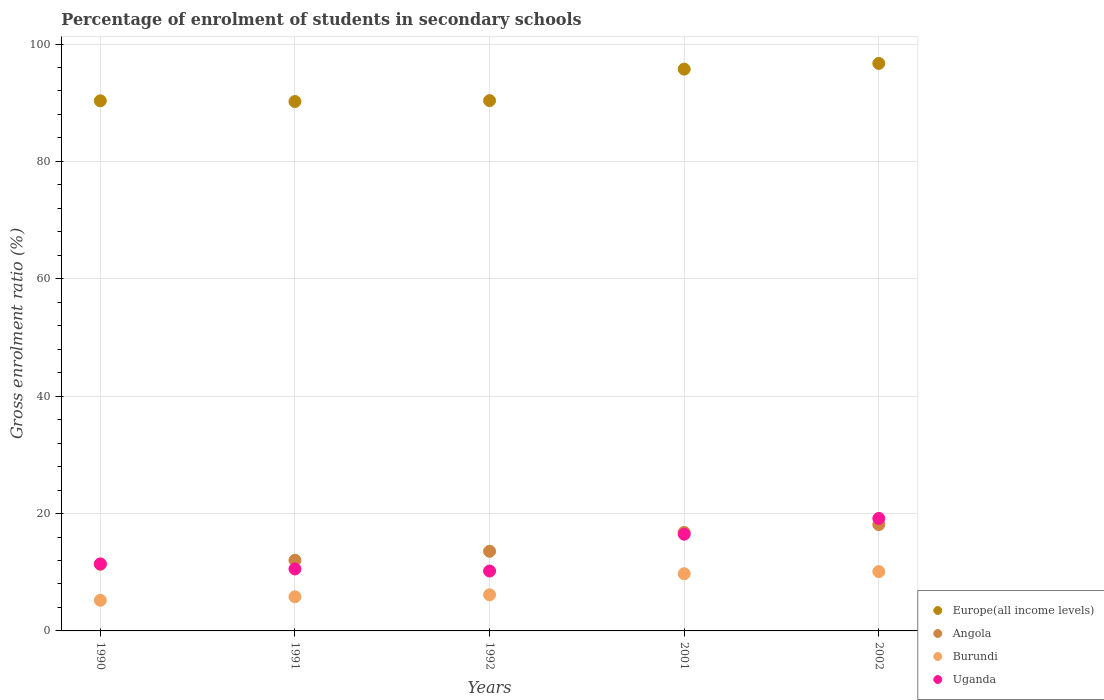How many different coloured dotlines are there?
Provide a short and direct response. 4. What is the percentage of students enrolled in secondary schools in Europe(all income levels) in 1990?
Make the answer very short. 90.32. Across all years, what is the maximum percentage of students enrolled in secondary schools in Europe(all income levels)?
Give a very brief answer. 96.69. Across all years, what is the minimum percentage of students enrolled in secondary schools in Angola?
Your answer should be very brief. 11.36. In which year was the percentage of students enrolled in secondary schools in Uganda minimum?
Keep it short and to the point. 1992. What is the total percentage of students enrolled in secondary schools in Europe(all income levels) in the graph?
Offer a terse response. 463.3. What is the difference between the percentage of students enrolled in secondary schools in Europe(all income levels) in 1990 and that in 2002?
Ensure brevity in your answer.  -6.37. What is the difference between the percentage of students enrolled in secondary schools in Uganda in 2001 and the percentage of students enrolled in secondary schools in Europe(all income levels) in 1990?
Provide a short and direct response. -73.85. What is the average percentage of students enrolled in secondary schools in Burundi per year?
Ensure brevity in your answer.  7.41. In the year 1992, what is the difference between the percentage of students enrolled in secondary schools in Uganda and percentage of students enrolled in secondary schools in Burundi?
Offer a very short reply. 4.05. What is the ratio of the percentage of students enrolled in secondary schools in Uganda in 1990 to that in 2002?
Provide a short and direct response. 0.6. Is the difference between the percentage of students enrolled in secondary schools in Uganda in 1992 and 2002 greater than the difference between the percentage of students enrolled in secondary schools in Burundi in 1992 and 2002?
Your answer should be very brief. No. What is the difference between the highest and the second highest percentage of students enrolled in secondary schools in Uganda?
Make the answer very short. 2.69. What is the difference between the highest and the lowest percentage of students enrolled in secondary schools in Burundi?
Offer a very short reply. 4.89. Is the sum of the percentage of students enrolled in secondary schools in Angola in 1991 and 1992 greater than the maximum percentage of students enrolled in secondary schools in Europe(all income levels) across all years?
Keep it short and to the point. No. Is it the case that in every year, the sum of the percentage of students enrolled in secondary schools in Burundi and percentage of students enrolled in secondary schools in Angola  is greater than the sum of percentage of students enrolled in secondary schools in Europe(all income levels) and percentage of students enrolled in secondary schools in Uganda?
Your response must be concise. Yes. Is the percentage of students enrolled in secondary schools in Burundi strictly greater than the percentage of students enrolled in secondary schools in Angola over the years?
Offer a terse response. No. Is the percentage of students enrolled in secondary schools in Europe(all income levels) strictly less than the percentage of students enrolled in secondary schools in Uganda over the years?
Make the answer very short. No. How many years are there in the graph?
Give a very brief answer. 5. What is the difference between two consecutive major ticks on the Y-axis?
Your response must be concise. 20. Does the graph contain any zero values?
Keep it short and to the point. No. Where does the legend appear in the graph?
Ensure brevity in your answer.  Bottom right. How are the legend labels stacked?
Give a very brief answer. Vertical. What is the title of the graph?
Your answer should be compact. Percentage of enrolment of students in secondary schools. Does "United Kingdom" appear as one of the legend labels in the graph?
Your answer should be compact. No. What is the label or title of the X-axis?
Offer a terse response. Years. What is the label or title of the Y-axis?
Your response must be concise. Gross enrolment ratio (%). What is the Gross enrolment ratio (%) in Europe(all income levels) in 1990?
Your response must be concise. 90.32. What is the Gross enrolment ratio (%) of Angola in 1990?
Offer a terse response. 11.36. What is the Gross enrolment ratio (%) of Burundi in 1990?
Make the answer very short. 5.22. What is the Gross enrolment ratio (%) in Uganda in 1990?
Make the answer very short. 11.42. What is the Gross enrolment ratio (%) in Europe(all income levels) in 1991?
Ensure brevity in your answer.  90.2. What is the Gross enrolment ratio (%) of Angola in 1991?
Keep it short and to the point. 12.04. What is the Gross enrolment ratio (%) in Burundi in 1991?
Your response must be concise. 5.82. What is the Gross enrolment ratio (%) in Uganda in 1991?
Make the answer very short. 10.56. What is the Gross enrolment ratio (%) in Europe(all income levels) in 1992?
Offer a terse response. 90.36. What is the Gross enrolment ratio (%) of Angola in 1992?
Provide a short and direct response. 13.57. What is the Gross enrolment ratio (%) in Burundi in 1992?
Offer a very short reply. 6.16. What is the Gross enrolment ratio (%) of Uganda in 1992?
Your answer should be very brief. 10.2. What is the Gross enrolment ratio (%) in Europe(all income levels) in 2001?
Offer a terse response. 95.72. What is the Gross enrolment ratio (%) in Angola in 2001?
Provide a short and direct response. 16.78. What is the Gross enrolment ratio (%) of Burundi in 2001?
Make the answer very short. 9.75. What is the Gross enrolment ratio (%) of Uganda in 2001?
Offer a very short reply. 16.48. What is the Gross enrolment ratio (%) of Europe(all income levels) in 2002?
Keep it short and to the point. 96.69. What is the Gross enrolment ratio (%) of Angola in 2002?
Make the answer very short. 18.11. What is the Gross enrolment ratio (%) of Burundi in 2002?
Offer a very short reply. 10.11. What is the Gross enrolment ratio (%) of Uganda in 2002?
Your answer should be compact. 19.16. Across all years, what is the maximum Gross enrolment ratio (%) in Europe(all income levels)?
Offer a very short reply. 96.69. Across all years, what is the maximum Gross enrolment ratio (%) of Angola?
Provide a short and direct response. 18.11. Across all years, what is the maximum Gross enrolment ratio (%) of Burundi?
Your response must be concise. 10.11. Across all years, what is the maximum Gross enrolment ratio (%) in Uganda?
Offer a terse response. 19.16. Across all years, what is the minimum Gross enrolment ratio (%) in Europe(all income levels)?
Ensure brevity in your answer.  90.2. Across all years, what is the minimum Gross enrolment ratio (%) of Angola?
Provide a short and direct response. 11.36. Across all years, what is the minimum Gross enrolment ratio (%) of Burundi?
Provide a succinct answer. 5.22. Across all years, what is the minimum Gross enrolment ratio (%) of Uganda?
Give a very brief answer. 10.2. What is the total Gross enrolment ratio (%) in Europe(all income levels) in the graph?
Provide a succinct answer. 463.3. What is the total Gross enrolment ratio (%) of Angola in the graph?
Offer a very short reply. 71.87. What is the total Gross enrolment ratio (%) of Burundi in the graph?
Your answer should be compact. 37.05. What is the total Gross enrolment ratio (%) of Uganda in the graph?
Ensure brevity in your answer.  67.82. What is the difference between the Gross enrolment ratio (%) in Europe(all income levels) in 1990 and that in 1991?
Ensure brevity in your answer.  0.12. What is the difference between the Gross enrolment ratio (%) of Angola in 1990 and that in 1991?
Ensure brevity in your answer.  -0.68. What is the difference between the Gross enrolment ratio (%) in Burundi in 1990 and that in 1991?
Keep it short and to the point. -0.6. What is the difference between the Gross enrolment ratio (%) of Uganda in 1990 and that in 1991?
Offer a terse response. 0.86. What is the difference between the Gross enrolment ratio (%) in Europe(all income levels) in 1990 and that in 1992?
Offer a very short reply. -0.04. What is the difference between the Gross enrolment ratio (%) of Angola in 1990 and that in 1992?
Ensure brevity in your answer.  -2.21. What is the difference between the Gross enrolment ratio (%) in Burundi in 1990 and that in 1992?
Keep it short and to the point. -0.94. What is the difference between the Gross enrolment ratio (%) in Uganda in 1990 and that in 1992?
Ensure brevity in your answer.  1.21. What is the difference between the Gross enrolment ratio (%) in Europe(all income levels) in 1990 and that in 2001?
Your answer should be compact. -5.4. What is the difference between the Gross enrolment ratio (%) in Angola in 1990 and that in 2001?
Provide a short and direct response. -5.43. What is the difference between the Gross enrolment ratio (%) of Burundi in 1990 and that in 2001?
Provide a short and direct response. -4.53. What is the difference between the Gross enrolment ratio (%) of Uganda in 1990 and that in 2001?
Your response must be concise. -5.06. What is the difference between the Gross enrolment ratio (%) in Europe(all income levels) in 1990 and that in 2002?
Keep it short and to the point. -6.37. What is the difference between the Gross enrolment ratio (%) in Angola in 1990 and that in 2002?
Offer a terse response. -6.76. What is the difference between the Gross enrolment ratio (%) in Burundi in 1990 and that in 2002?
Ensure brevity in your answer.  -4.89. What is the difference between the Gross enrolment ratio (%) of Uganda in 1990 and that in 2002?
Ensure brevity in your answer.  -7.75. What is the difference between the Gross enrolment ratio (%) in Europe(all income levels) in 1991 and that in 1992?
Your answer should be very brief. -0.16. What is the difference between the Gross enrolment ratio (%) of Angola in 1991 and that in 1992?
Keep it short and to the point. -1.53. What is the difference between the Gross enrolment ratio (%) in Burundi in 1991 and that in 1992?
Make the answer very short. -0.33. What is the difference between the Gross enrolment ratio (%) in Uganda in 1991 and that in 1992?
Provide a succinct answer. 0.35. What is the difference between the Gross enrolment ratio (%) of Europe(all income levels) in 1991 and that in 2001?
Your response must be concise. -5.52. What is the difference between the Gross enrolment ratio (%) in Angola in 1991 and that in 2001?
Give a very brief answer. -4.75. What is the difference between the Gross enrolment ratio (%) of Burundi in 1991 and that in 2001?
Give a very brief answer. -3.92. What is the difference between the Gross enrolment ratio (%) in Uganda in 1991 and that in 2001?
Your response must be concise. -5.92. What is the difference between the Gross enrolment ratio (%) of Europe(all income levels) in 1991 and that in 2002?
Your response must be concise. -6.49. What is the difference between the Gross enrolment ratio (%) in Angola in 1991 and that in 2002?
Offer a very short reply. -6.08. What is the difference between the Gross enrolment ratio (%) in Burundi in 1991 and that in 2002?
Provide a succinct answer. -4.29. What is the difference between the Gross enrolment ratio (%) in Uganda in 1991 and that in 2002?
Keep it short and to the point. -8.61. What is the difference between the Gross enrolment ratio (%) in Europe(all income levels) in 1992 and that in 2001?
Your answer should be very brief. -5.36. What is the difference between the Gross enrolment ratio (%) of Angola in 1992 and that in 2001?
Offer a terse response. -3.22. What is the difference between the Gross enrolment ratio (%) in Burundi in 1992 and that in 2001?
Provide a succinct answer. -3.59. What is the difference between the Gross enrolment ratio (%) in Uganda in 1992 and that in 2001?
Make the answer very short. -6.27. What is the difference between the Gross enrolment ratio (%) in Europe(all income levels) in 1992 and that in 2002?
Your response must be concise. -6.34. What is the difference between the Gross enrolment ratio (%) in Angola in 1992 and that in 2002?
Your response must be concise. -4.55. What is the difference between the Gross enrolment ratio (%) of Burundi in 1992 and that in 2002?
Your response must be concise. -3.95. What is the difference between the Gross enrolment ratio (%) of Uganda in 1992 and that in 2002?
Offer a terse response. -8.96. What is the difference between the Gross enrolment ratio (%) of Europe(all income levels) in 2001 and that in 2002?
Offer a very short reply. -0.97. What is the difference between the Gross enrolment ratio (%) of Angola in 2001 and that in 2002?
Your answer should be compact. -1.33. What is the difference between the Gross enrolment ratio (%) in Burundi in 2001 and that in 2002?
Offer a very short reply. -0.36. What is the difference between the Gross enrolment ratio (%) in Uganda in 2001 and that in 2002?
Give a very brief answer. -2.69. What is the difference between the Gross enrolment ratio (%) in Europe(all income levels) in 1990 and the Gross enrolment ratio (%) in Angola in 1991?
Your answer should be compact. 78.28. What is the difference between the Gross enrolment ratio (%) of Europe(all income levels) in 1990 and the Gross enrolment ratio (%) of Burundi in 1991?
Provide a succinct answer. 84.5. What is the difference between the Gross enrolment ratio (%) in Europe(all income levels) in 1990 and the Gross enrolment ratio (%) in Uganda in 1991?
Offer a very short reply. 79.77. What is the difference between the Gross enrolment ratio (%) in Angola in 1990 and the Gross enrolment ratio (%) in Burundi in 1991?
Offer a terse response. 5.54. What is the difference between the Gross enrolment ratio (%) of Angola in 1990 and the Gross enrolment ratio (%) of Uganda in 1991?
Provide a succinct answer. 0.8. What is the difference between the Gross enrolment ratio (%) of Burundi in 1990 and the Gross enrolment ratio (%) of Uganda in 1991?
Provide a succinct answer. -5.34. What is the difference between the Gross enrolment ratio (%) in Europe(all income levels) in 1990 and the Gross enrolment ratio (%) in Angola in 1992?
Your response must be concise. 76.75. What is the difference between the Gross enrolment ratio (%) in Europe(all income levels) in 1990 and the Gross enrolment ratio (%) in Burundi in 1992?
Offer a terse response. 84.16. What is the difference between the Gross enrolment ratio (%) in Europe(all income levels) in 1990 and the Gross enrolment ratio (%) in Uganda in 1992?
Keep it short and to the point. 80.12. What is the difference between the Gross enrolment ratio (%) of Angola in 1990 and the Gross enrolment ratio (%) of Burundi in 1992?
Your answer should be very brief. 5.2. What is the difference between the Gross enrolment ratio (%) of Angola in 1990 and the Gross enrolment ratio (%) of Uganda in 1992?
Your answer should be compact. 1.15. What is the difference between the Gross enrolment ratio (%) of Burundi in 1990 and the Gross enrolment ratio (%) of Uganda in 1992?
Give a very brief answer. -4.99. What is the difference between the Gross enrolment ratio (%) of Europe(all income levels) in 1990 and the Gross enrolment ratio (%) of Angola in 2001?
Provide a short and direct response. 73.54. What is the difference between the Gross enrolment ratio (%) in Europe(all income levels) in 1990 and the Gross enrolment ratio (%) in Burundi in 2001?
Make the answer very short. 80.58. What is the difference between the Gross enrolment ratio (%) of Europe(all income levels) in 1990 and the Gross enrolment ratio (%) of Uganda in 2001?
Your answer should be compact. 73.85. What is the difference between the Gross enrolment ratio (%) of Angola in 1990 and the Gross enrolment ratio (%) of Burundi in 2001?
Your answer should be very brief. 1.61. What is the difference between the Gross enrolment ratio (%) of Angola in 1990 and the Gross enrolment ratio (%) of Uganda in 2001?
Provide a succinct answer. -5.12. What is the difference between the Gross enrolment ratio (%) of Burundi in 1990 and the Gross enrolment ratio (%) of Uganda in 2001?
Offer a very short reply. -11.26. What is the difference between the Gross enrolment ratio (%) of Europe(all income levels) in 1990 and the Gross enrolment ratio (%) of Angola in 2002?
Your answer should be compact. 72.21. What is the difference between the Gross enrolment ratio (%) of Europe(all income levels) in 1990 and the Gross enrolment ratio (%) of Burundi in 2002?
Provide a short and direct response. 80.21. What is the difference between the Gross enrolment ratio (%) in Europe(all income levels) in 1990 and the Gross enrolment ratio (%) in Uganda in 2002?
Keep it short and to the point. 71.16. What is the difference between the Gross enrolment ratio (%) in Angola in 1990 and the Gross enrolment ratio (%) in Burundi in 2002?
Provide a short and direct response. 1.25. What is the difference between the Gross enrolment ratio (%) in Angola in 1990 and the Gross enrolment ratio (%) in Uganda in 2002?
Ensure brevity in your answer.  -7.81. What is the difference between the Gross enrolment ratio (%) of Burundi in 1990 and the Gross enrolment ratio (%) of Uganda in 2002?
Keep it short and to the point. -13.95. What is the difference between the Gross enrolment ratio (%) in Europe(all income levels) in 1991 and the Gross enrolment ratio (%) in Angola in 1992?
Make the answer very short. 76.63. What is the difference between the Gross enrolment ratio (%) of Europe(all income levels) in 1991 and the Gross enrolment ratio (%) of Burundi in 1992?
Give a very brief answer. 84.04. What is the difference between the Gross enrolment ratio (%) in Europe(all income levels) in 1991 and the Gross enrolment ratio (%) in Uganda in 1992?
Provide a succinct answer. 80. What is the difference between the Gross enrolment ratio (%) of Angola in 1991 and the Gross enrolment ratio (%) of Burundi in 1992?
Your response must be concise. 5.88. What is the difference between the Gross enrolment ratio (%) of Angola in 1991 and the Gross enrolment ratio (%) of Uganda in 1992?
Your answer should be very brief. 1.83. What is the difference between the Gross enrolment ratio (%) in Burundi in 1991 and the Gross enrolment ratio (%) in Uganda in 1992?
Provide a short and direct response. -4.38. What is the difference between the Gross enrolment ratio (%) in Europe(all income levels) in 1991 and the Gross enrolment ratio (%) in Angola in 2001?
Offer a very short reply. 73.42. What is the difference between the Gross enrolment ratio (%) of Europe(all income levels) in 1991 and the Gross enrolment ratio (%) of Burundi in 2001?
Your answer should be very brief. 80.46. What is the difference between the Gross enrolment ratio (%) in Europe(all income levels) in 1991 and the Gross enrolment ratio (%) in Uganda in 2001?
Offer a terse response. 73.72. What is the difference between the Gross enrolment ratio (%) of Angola in 1991 and the Gross enrolment ratio (%) of Burundi in 2001?
Your answer should be very brief. 2.29. What is the difference between the Gross enrolment ratio (%) of Angola in 1991 and the Gross enrolment ratio (%) of Uganda in 2001?
Ensure brevity in your answer.  -4.44. What is the difference between the Gross enrolment ratio (%) in Burundi in 1991 and the Gross enrolment ratio (%) in Uganda in 2001?
Keep it short and to the point. -10.65. What is the difference between the Gross enrolment ratio (%) of Europe(all income levels) in 1991 and the Gross enrolment ratio (%) of Angola in 2002?
Provide a short and direct response. 72.09. What is the difference between the Gross enrolment ratio (%) of Europe(all income levels) in 1991 and the Gross enrolment ratio (%) of Burundi in 2002?
Your answer should be compact. 80.09. What is the difference between the Gross enrolment ratio (%) in Europe(all income levels) in 1991 and the Gross enrolment ratio (%) in Uganda in 2002?
Make the answer very short. 71.04. What is the difference between the Gross enrolment ratio (%) of Angola in 1991 and the Gross enrolment ratio (%) of Burundi in 2002?
Offer a terse response. 1.93. What is the difference between the Gross enrolment ratio (%) in Angola in 1991 and the Gross enrolment ratio (%) in Uganda in 2002?
Your answer should be compact. -7.13. What is the difference between the Gross enrolment ratio (%) in Burundi in 1991 and the Gross enrolment ratio (%) in Uganda in 2002?
Provide a short and direct response. -13.34. What is the difference between the Gross enrolment ratio (%) in Europe(all income levels) in 1992 and the Gross enrolment ratio (%) in Angola in 2001?
Provide a short and direct response. 73.57. What is the difference between the Gross enrolment ratio (%) of Europe(all income levels) in 1992 and the Gross enrolment ratio (%) of Burundi in 2001?
Your answer should be very brief. 80.61. What is the difference between the Gross enrolment ratio (%) in Europe(all income levels) in 1992 and the Gross enrolment ratio (%) in Uganda in 2001?
Provide a succinct answer. 73.88. What is the difference between the Gross enrolment ratio (%) of Angola in 1992 and the Gross enrolment ratio (%) of Burundi in 2001?
Make the answer very short. 3.82. What is the difference between the Gross enrolment ratio (%) in Angola in 1992 and the Gross enrolment ratio (%) in Uganda in 2001?
Offer a terse response. -2.91. What is the difference between the Gross enrolment ratio (%) of Burundi in 1992 and the Gross enrolment ratio (%) of Uganda in 2001?
Your response must be concise. -10.32. What is the difference between the Gross enrolment ratio (%) in Europe(all income levels) in 1992 and the Gross enrolment ratio (%) in Angola in 2002?
Your answer should be compact. 72.24. What is the difference between the Gross enrolment ratio (%) of Europe(all income levels) in 1992 and the Gross enrolment ratio (%) of Burundi in 2002?
Your answer should be very brief. 80.25. What is the difference between the Gross enrolment ratio (%) of Europe(all income levels) in 1992 and the Gross enrolment ratio (%) of Uganda in 2002?
Offer a very short reply. 71.19. What is the difference between the Gross enrolment ratio (%) in Angola in 1992 and the Gross enrolment ratio (%) in Burundi in 2002?
Make the answer very short. 3.46. What is the difference between the Gross enrolment ratio (%) of Angola in 1992 and the Gross enrolment ratio (%) of Uganda in 2002?
Your answer should be very brief. -5.6. What is the difference between the Gross enrolment ratio (%) of Burundi in 1992 and the Gross enrolment ratio (%) of Uganda in 2002?
Provide a succinct answer. -13.01. What is the difference between the Gross enrolment ratio (%) in Europe(all income levels) in 2001 and the Gross enrolment ratio (%) in Angola in 2002?
Your response must be concise. 77.61. What is the difference between the Gross enrolment ratio (%) of Europe(all income levels) in 2001 and the Gross enrolment ratio (%) of Burundi in 2002?
Make the answer very short. 85.61. What is the difference between the Gross enrolment ratio (%) in Europe(all income levels) in 2001 and the Gross enrolment ratio (%) in Uganda in 2002?
Ensure brevity in your answer.  76.56. What is the difference between the Gross enrolment ratio (%) in Angola in 2001 and the Gross enrolment ratio (%) in Burundi in 2002?
Provide a succinct answer. 6.67. What is the difference between the Gross enrolment ratio (%) of Angola in 2001 and the Gross enrolment ratio (%) of Uganda in 2002?
Offer a terse response. -2.38. What is the difference between the Gross enrolment ratio (%) of Burundi in 2001 and the Gross enrolment ratio (%) of Uganda in 2002?
Give a very brief answer. -9.42. What is the average Gross enrolment ratio (%) of Europe(all income levels) per year?
Provide a succinct answer. 92.66. What is the average Gross enrolment ratio (%) in Angola per year?
Your answer should be compact. 14.37. What is the average Gross enrolment ratio (%) in Burundi per year?
Offer a very short reply. 7.41. What is the average Gross enrolment ratio (%) of Uganda per year?
Your answer should be compact. 13.56. In the year 1990, what is the difference between the Gross enrolment ratio (%) of Europe(all income levels) and Gross enrolment ratio (%) of Angola?
Provide a succinct answer. 78.96. In the year 1990, what is the difference between the Gross enrolment ratio (%) in Europe(all income levels) and Gross enrolment ratio (%) in Burundi?
Provide a succinct answer. 85.1. In the year 1990, what is the difference between the Gross enrolment ratio (%) in Europe(all income levels) and Gross enrolment ratio (%) in Uganda?
Keep it short and to the point. 78.9. In the year 1990, what is the difference between the Gross enrolment ratio (%) in Angola and Gross enrolment ratio (%) in Burundi?
Provide a short and direct response. 6.14. In the year 1990, what is the difference between the Gross enrolment ratio (%) of Angola and Gross enrolment ratio (%) of Uganda?
Offer a very short reply. -0.06. In the year 1990, what is the difference between the Gross enrolment ratio (%) in Burundi and Gross enrolment ratio (%) in Uganda?
Ensure brevity in your answer.  -6.2. In the year 1991, what is the difference between the Gross enrolment ratio (%) in Europe(all income levels) and Gross enrolment ratio (%) in Angola?
Ensure brevity in your answer.  78.16. In the year 1991, what is the difference between the Gross enrolment ratio (%) in Europe(all income levels) and Gross enrolment ratio (%) in Burundi?
Give a very brief answer. 84.38. In the year 1991, what is the difference between the Gross enrolment ratio (%) in Europe(all income levels) and Gross enrolment ratio (%) in Uganda?
Make the answer very short. 79.65. In the year 1991, what is the difference between the Gross enrolment ratio (%) in Angola and Gross enrolment ratio (%) in Burundi?
Your answer should be compact. 6.22. In the year 1991, what is the difference between the Gross enrolment ratio (%) in Angola and Gross enrolment ratio (%) in Uganda?
Give a very brief answer. 1.48. In the year 1991, what is the difference between the Gross enrolment ratio (%) in Burundi and Gross enrolment ratio (%) in Uganda?
Your answer should be very brief. -4.73. In the year 1992, what is the difference between the Gross enrolment ratio (%) in Europe(all income levels) and Gross enrolment ratio (%) in Angola?
Make the answer very short. 76.79. In the year 1992, what is the difference between the Gross enrolment ratio (%) of Europe(all income levels) and Gross enrolment ratio (%) of Burundi?
Your response must be concise. 84.2. In the year 1992, what is the difference between the Gross enrolment ratio (%) of Europe(all income levels) and Gross enrolment ratio (%) of Uganda?
Offer a terse response. 80.15. In the year 1992, what is the difference between the Gross enrolment ratio (%) in Angola and Gross enrolment ratio (%) in Burundi?
Your answer should be compact. 7.41. In the year 1992, what is the difference between the Gross enrolment ratio (%) of Angola and Gross enrolment ratio (%) of Uganda?
Offer a terse response. 3.36. In the year 1992, what is the difference between the Gross enrolment ratio (%) in Burundi and Gross enrolment ratio (%) in Uganda?
Make the answer very short. -4.05. In the year 2001, what is the difference between the Gross enrolment ratio (%) of Europe(all income levels) and Gross enrolment ratio (%) of Angola?
Offer a very short reply. 78.94. In the year 2001, what is the difference between the Gross enrolment ratio (%) of Europe(all income levels) and Gross enrolment ratio (%) of Burundi?
Give a very brief answer. 85.98. In the year 2001, what is the difference between the Gross enrolment ratio (%) in Europe(all income levels) and Gross enrolment ratio (%) in Uganda?
Your answer should be compact. 79.25. In the year 2001, what is the difference between the Gross enrolment ratio (%) in Angola and Gross enrolment ratio (%) in Burundi?
Your answer should be very brief. 7.04. In the year 2001, what is the difference between the Gross enrolment ratio (%) in Angola and Gross enrolment ratio (%) in Uganda?
Keep it short and to the point. 0.31. In the year 2001, what is the difference between the Gross enrolment ratio (%) in Burundi and Gross enrolment ratio (%) in Uganda?
Ensure brevity in your answer.  -6.73. In the year 2002, what is the difference between the Gross enrolment ratio (%) in Europe(all income levels) and Gross enrolment ratio (%) in Angola?
Offer a terse response. 78.58. In the year 2002, what is the difference between the Gross enrolment ratio (%) of Europe(all income levels) and Gross enrolment ratio (%) of Burundi?
Ensure brevity in your answer.  86.58. In the year 2002, what is the difference between the Gross enrolment ratio (%) in Europe(all income levels) and Gross enrolment ratio (%) in Uganda?
Keep it short and to the point. 77.53. In the year 2002, what is the difference between the Gross enrolment ratio (%) in Angola and Gross enrolment ratio (%) in Burundi?
Keep it short and to the point. 8. In the year 2002, what is the difference between the Gross enrolment ratio (%) of Angola and Gross enrolment ratio (%) of Uganda?
Your answer should be compact. -1.05. In the year 2002, what is the difference between the Gross enrolment ratio (%) of Burundi and Gross enrolment ratio (%) of Uganda?
Keep it short and to the point. -9.05. What is the ratio of the Gross enrolment ratio (%) of Angola in 1990 to that in 1991?
Give a very brief answer. 0.94. What is the ratio of the Gross enrolment ratio (%) in Burundi in 1990 to that in 1991?
Your response must be concise. 0.9. What is the ratio of the Gross enrolment ratio (%) in Uganda in 1990 to that in 1991?
Keep it short and to the point. 1.08. What is the ratio of the Gross enrolment ratio (%) of Angola in 1990 to that in 1992?
Offer a terse response. 0.84. What is the ratio of the Gross enrolment ratio (%) in Burundi in 1990 to that in 1992?
Keep it short and to the point. 0.85. What is the ratio of the Gross enrolment ratio (%) of Uganda in 1990 to that in 1992?
Ensure brevity in your answer.  1.12. What is the ratio of the Gross enrolment ratio (%) of Europe(all income levels) in 1990 to that in 2001?
Provide a short and direct response. 0.94. What is the ratio of the Gross enrolment ratio (%) of Angola in 1990 to that in 2001?
Offer a very short reply. 0.68. What is the ratio of the Gross enrolment ratio (%) in Burundi in 1990 to that in 2001?
Offer a terse response. 0.54. What is the ratio of the Gross enrolment ratio (%) in Uganda in 1990 to that in 2001?
Provide a succinct answer. 0.69. What is the ratio of the Gross enrolment ratio (%) in Europe(all income levels) in 1990 to that in 2002?
Your response must be concise. 0.93. What is the ratio of the Gross enrolment ratio (%) of Angola in 1990 to that in 2002?
Keep it short and to the point. 0.63. What is the ratio of the Gross enrolment ratio (%) of Burundi in 1990 to that in 2002?
Ensure brevity in your answer.  0.52. What is the ratio of the Gross enrolment ratio (%) of Uganda in 1990 to that in 2002?
Your response must be concise. 0.6. What is the ratio of the Gross enrolment ratio (%) in Angola in 1991 to that in 1992?
Ensure brevity in your answer.  0.89. What is the ratio of the Gross enrolment ratio (%) of Burundi in 1991 to that in 1992?
Make the answer very short. 0.95. What is the ratio of the Gross enrolment ratio (%) of Uganda in 1991 to that in 1992?
Keep it short and to the point. 1.03. What is the ratio of the Gross enrolment ratio (%) of Europe(all income levels) in 1991 to that in 2001?
Your response must be concise. 0.94. What is the ratio of the Gross enrolment ratio (%) of Angola in 1991 to that in 2001?
Offer a very short reply. 0.72. What is the ratio of the Gross enrolment ratio (%) in Burundi in 1991 to that in 2001?
Your answer should be compact. 0.6. What is the ratio of the Gross enrolment ratio (%) in Uganda in 1991 to that in 2001?
Provide a short and direct response. 0.64. What is the ratio of the Gross enrolment ratio (%) in Europe(all income levels) in 1991 to that in 2002?
Provide a succinct answer. 0.93. What is the ratio of the Gross enrolment ratio (%) of Angola in 1991 to that in 2002?
Your answer should be compact. 0.66. What is the ratio of the Gross enrolment ratio (%) in Burundi in 1991 to that in 2002?
Make the answer very short. 0.58. What is the ratio of the Gross enrolment ratio (%) in Uganda in 1991 to that in 2002?
Give a very brief answer. 0.55. What is the ratio of the Gross enrolment ratio (%) in Europe(all income levels) in 1992 to that in 2001?
Provide a short and direct response. 0.94. What is the ratio of the Gross enrolment ratio (%) in Angola in 1992 to that in 2001?
Your answer should be very brief. 0.81. What is the ratio of the Gross enrolment ratio (%) of Burundi in 1992 to that in 2001?
Your answer should be very brief. 0.63. What is the ratio of the Gross enrolment ratio (%) of Uganda in 1992 to that in 2001?
Give a very brief answer. 0.62. What is the ratio of the Gross enrolment ratio (%) in Europe(all income levels) in 1992 to that in 2002?
Give a very brief answer. 0.93. What is the ratio of the Gross enrolment ratio (%) in Angola in 1992 to that in 2002?
Your response must be concise. 0.75. What is the ratio of the Gross enrolment ratio (%) of Burundi in 1992 to that in 2002?
Your response must be concise. 0.61. What is the ratio of the Gross enrolment ratio (%) of Uganda in 1992 to that in 2002?
Offer a very short reply. 0.53. What is the ratio of the Gross enrolment ratio (%) of Europe(all income levels) in 2001 to that in 2002?
Give a very brief answer. 0.99. What is the ratio of the Gross enrolment ratio (%) in Angola in 2001 to that in 2002?
Provide a succinct answer. 0.93. What is the ratio of the Gross enrolment ratio (%) of Uganda in 2001 to that in 2002?
Keep it short and to the point. 0.86. What is the difference between the highest and the second highest Gross enrolment ratio (%) in Europe(all income levels)?
Offer a very short reply. 0.97. What is the difference between the highest and the second highest Gross enrolment ratio (%) of Angola?
Your answer should be compact. 1.33. What is the difference between the highest and the second highest Gross enrolment ratio (%) of Burundi?
Keep it short and to the point. 0.36. What is the difference between the highest and the second highest Gross enrolment ratio (%) in Uganda?
Your answer should be compact. 2.69. What is the difference between the highest and the lowest Gross enrolment ratio (%) in Europe(all income levels)?
Give a very brief answer. 6.49. What is the difference between the highest and the lowest Gross enrolment ratio (%) of Angola?
Your response must be concise. 6.76. What is the difference between the highest and the lowest Gross enrolment ratio (%) of Burundi?
Your response must be concise. 4.89. What is the difference between the highest and the lowest Gross enrolment ratio (%) in Uganda?
Offer a very short reply. 8.96. 